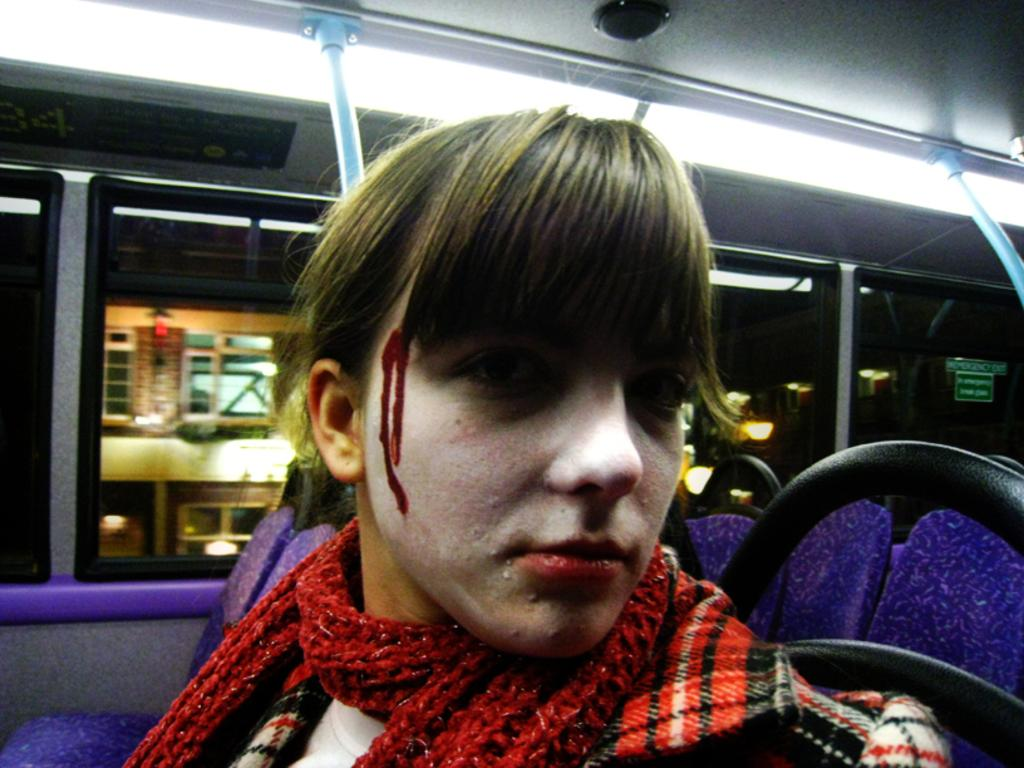What is the person in the image doing? There is a person sitting inside a vehicle in the image. What objects can be seen in the image besides the person and the vehicle? There are rods and boards visible in the image. What can be seen through the glass windows of the vehicle? Buildings and lights are visible through the glass windows of the vehicle. What is the price of the division shown in the image? There is no division present in the image, and therefore no price can be determined. 